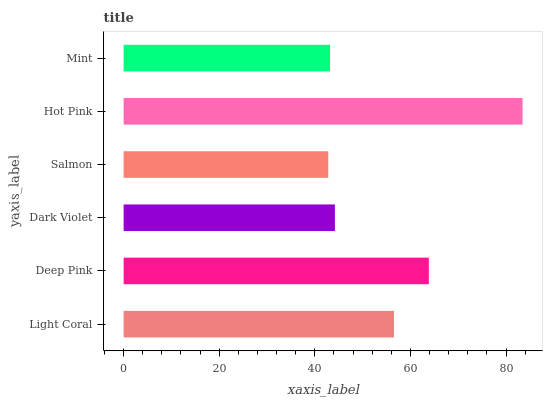Is Salmon the minimum?
Answer yes or no. Yes. Is Hot Pink the maximum?
Answer yes or no. Yes. Is Deep Pink the minimum?
Answer yes or no. No. Is Deep Pink the maximum?
Answer yes or no. No. Is Deep Pink greater than Light Coral?
Answer yes or no. Yes. Is Light Coral less than Deep Pink?
Answer yes or no. Yes. Is Light Coral greater than Deep Pink?
Answer yes or no. No. Is Deep Pink less than Light Coral?
Answer yes or no. No. Is Light Coral the high median?
Answer yes or no. Yes. Is Dark Violet the low median?
Answer yes or no. Yes. Is Hot Pink the high median?
Answer yes or no. No. Is Hot Pink the low median?
Answer yes or no. No. 